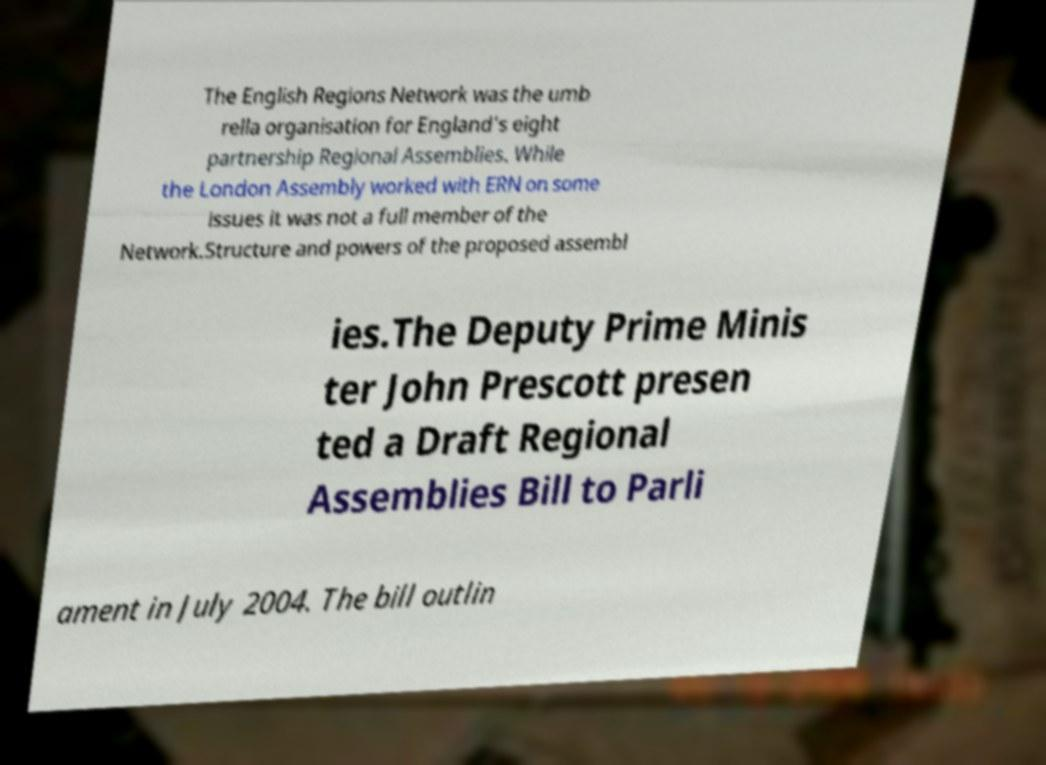There's text embedded in this image that I need extracted. Can you transcribe it verbatim? The English Regions Network was the umb rella organisation for England's eight partnership Regional Assemblies. While the London Assembly worked with ERN on some issues it was not a full member of the Network.Structure and powers of the proposed assembl ies.The Deputy Prime Minis ter John Prescott presen ted a Draft Regional Assemblies Bill to Parli ament in July 2004. The bill outlin 